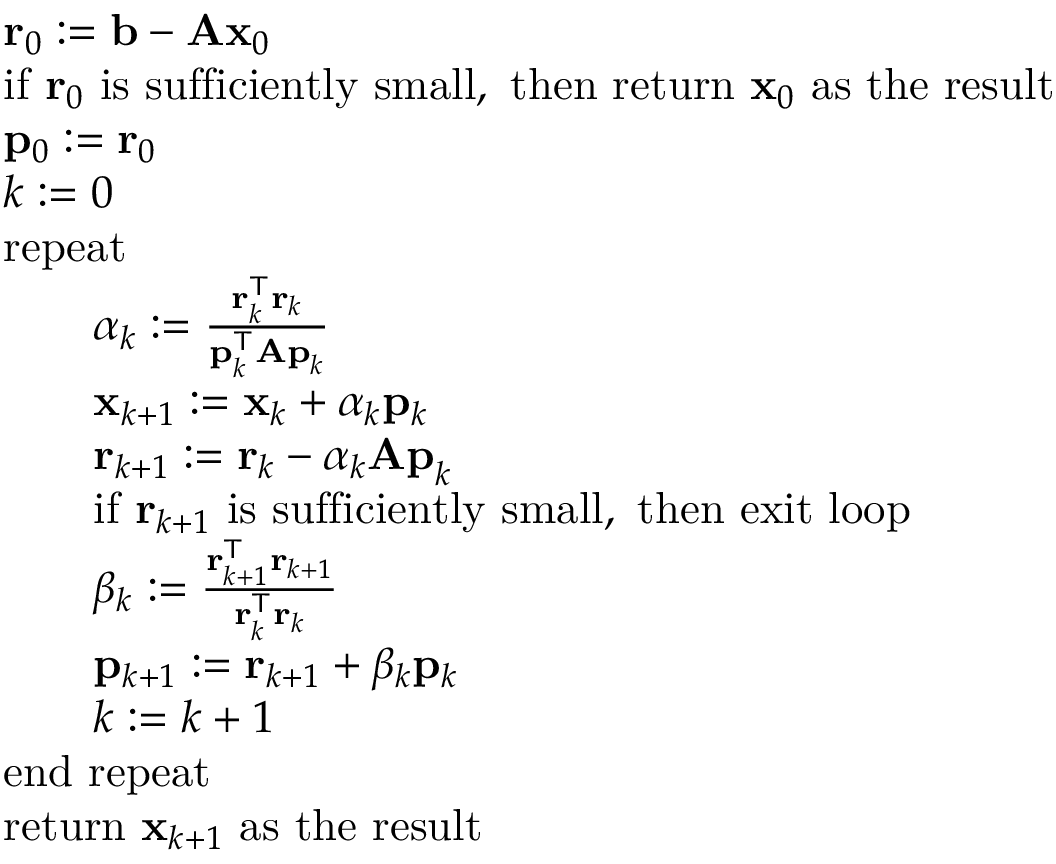<formula> <loc_0><loc_0><loc_500><loc_500>{ \begin{array} { r l } & { r _ { 0 } \colon = b - A x _ { 0 } } \\ & { { i f } r _ { 0 } { i s s u f f i c i e n t l y s m a l l , t h e n r e t u r n } x _ { 0 } { a s t h e r e s u l t } } \\ & { p _ { 0 } \colon = r _ { 0 } } \\ & { k \colon = 0 } \\ & { r e p e a t } \\ & { \quad \alpha _ { k } \colon = { \frac { r _ { k } ^ { T } r _ { k } } { p _ { k } ^ { T } A p _ { k } } } } \\ & { \quad x _ { k + 1 } \colon = x _ { k } + \alpha _ { k } p _ { k } } \\ & { \quad r _ { k + 1 } \colon = r _ { k } - \alpha _ { k } A p _ { k } } \\ & { \quad { i f } r _ { k + 1 } { i s s u f f i c i e n t l y s m a l l , t h e n e x i t l o o p } } \\ & { \quad \beta _ { k } \colon = { \frac { r _ { k + 1 } ^ { T } r _ { k + 1 } } { r _ { k } ^ { T } r _ { k } } } } \\ & { \quad p _ { k + 1 } \colon = r _ { k + 1 } + \beta _ { k } p _ { k } } \\ & { \quad k \colon = k + 1 } \\ & { e n d r e p e a t } \\ & { { r e t u r n } x _ { k + 1 } { a s t h e r e s u l t } } \end{array} }</formula> 